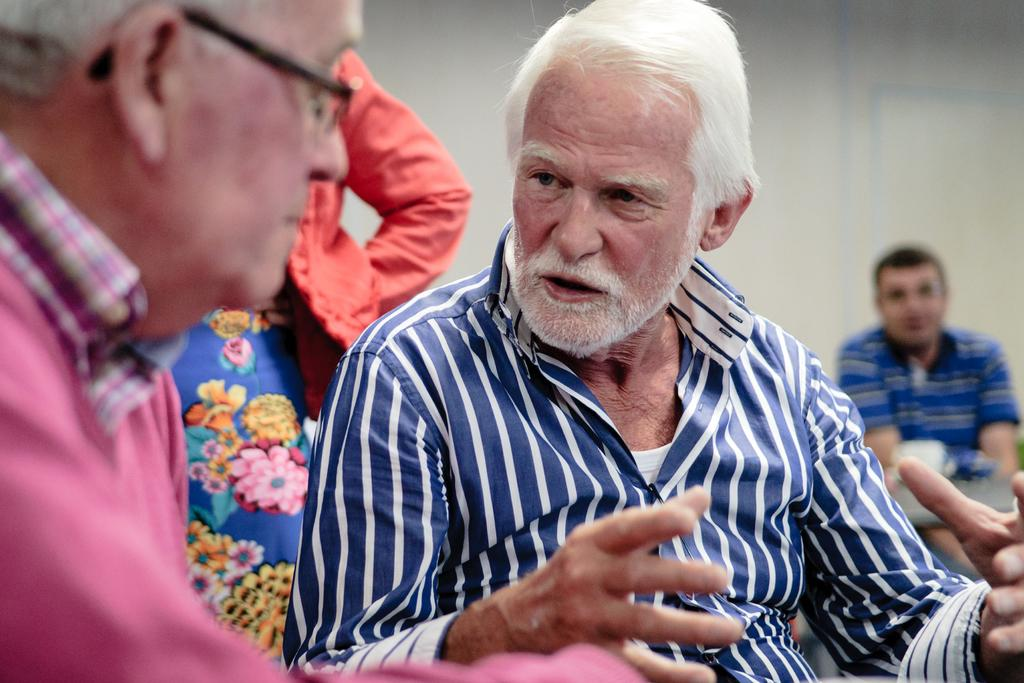What can be seen in the background of the image? There is a wall in the image. Are there any living beings in the image? Yes, there are people present in the image. What grade does the peace sign receive in the image? There is no peace sign present in the image, so it cannot be graded. 